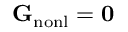Convert formula to latex. <formula><loc_0><loc_0><loc_500><loc_500>{ G } _ { n o n l } = { 0 }</formula> 